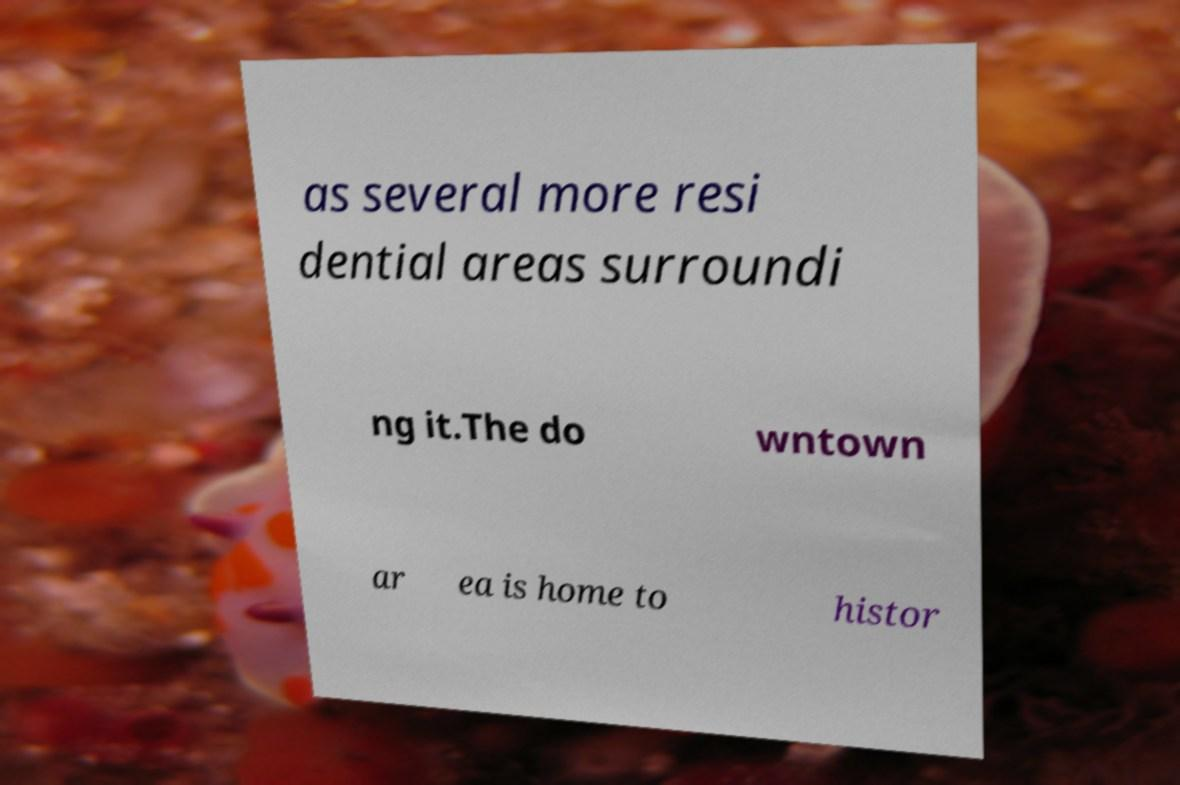Please identify and transcribe the text found in this image. as several more resi dential areas surroundi ng it.The do wntown ar ea is home to histor 